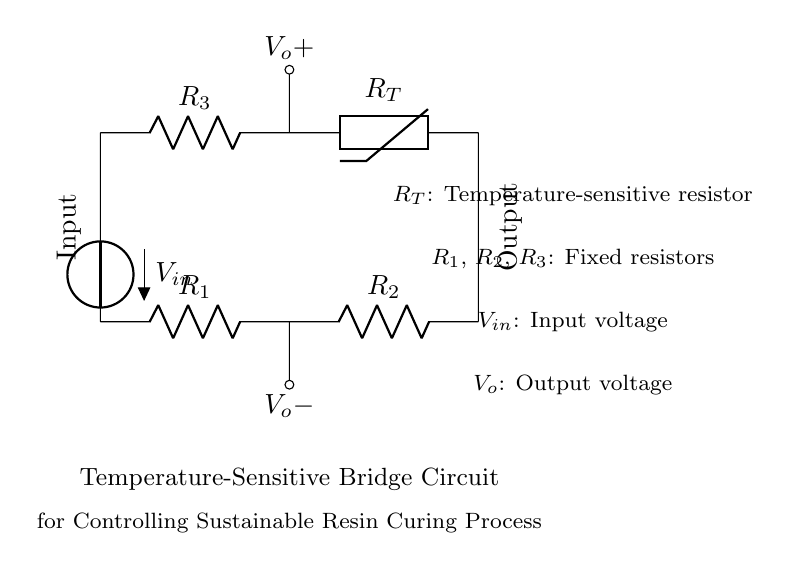What type of resistor is used in this circuit? The circuit includes a thermistor denoted as R_T, which is a temperature-sensitive resistor.
Answer: Thermistor What is the purpose of the fixed resistors R1, R2, and R3? These resistors are used to balance the bridge circuit, helping to determine the output voltage based on the resistance changes in the thermistor relative to them.
Answer: Balance the circuit How many resistors are present in this bridge circuit? There are three fixed resistors (R1, R2, R3) and one thermistor (R_T), totaling four resistors in the circuit.
Answer: Four What influences the output voltage V_o in this circuit? The output voltage V_o depends on the temperature changes affecting the thermistor (R_T), which alters its resistance, thus affecting the balance of the bridge and the resulting output voltage.
Answer: Temperature changes What is the input voltage denoted as in the circuit? The input voltage is indicated as V_in, which is provided to one side of the bridge circuit.
Answer: V_in Which component type is specifically designed to respond to temperature? The thermistor, marked as R_T, is specifically designed to change resistance in response to temperature variations.
Answer: Thermistor What does an increase in temperature do to the thermistor's resistance in this application? In most cases, for a negative temperature coefficient (NTC) thermistor, an increase in temperature causes the resistance to decrease, impacting the output voltage.
Answer: Decreases resistance 